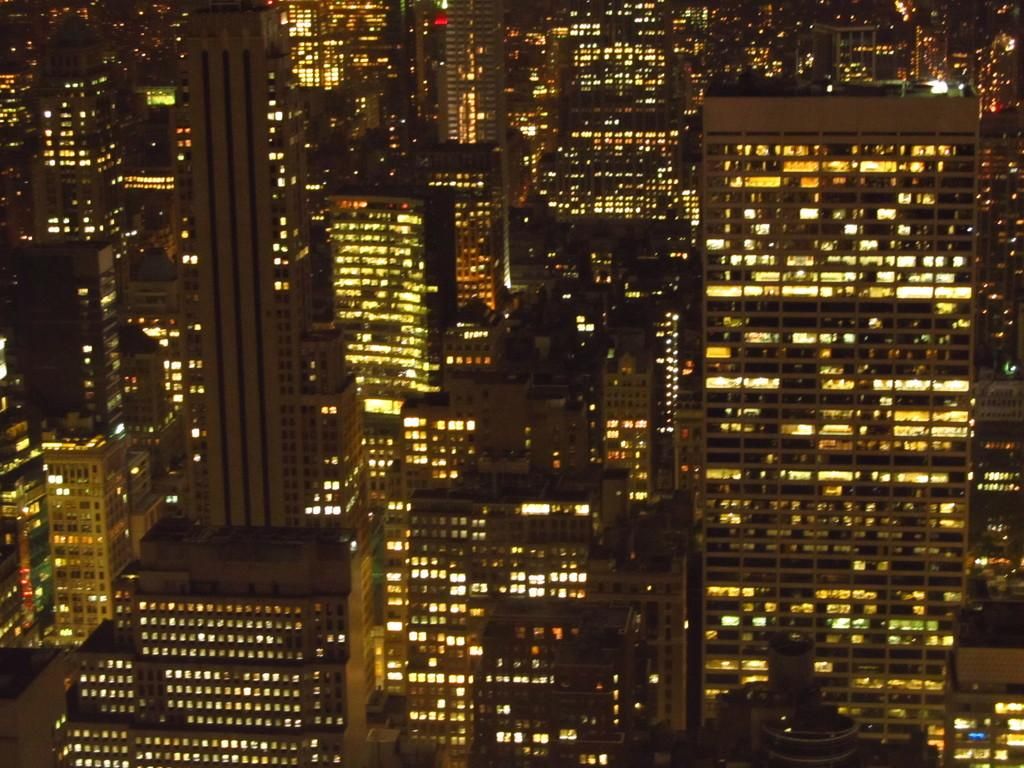What type of structures are present in the image? The image contains multiple buildings. When was the image taken? The image was taken at night. How are the buildings in the image visible despite the darkness? The buildings are illuminated with lights. What color is the tongue of the person standing in front of the buildings in the image? There is no person or tongue visible in the image; it only contains multiple buildings illuminated with lights. 